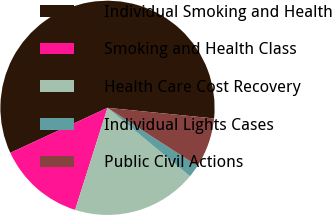Convert chart. <chart><loc_0><loc_0><loc_500><loc_500><pie_chart><fcel>Individual Smoking and Health<fcel>Smoking and Health Class<fcel>Health Care Cost Recovery<fcel>Individual Lights Cases<fcel>Public Civil Actions<nl><fcel>58.49%<fcel>13.21%<fcel>18.87%<fcel>1.89%<fcel>7.55%<nl></chart> 